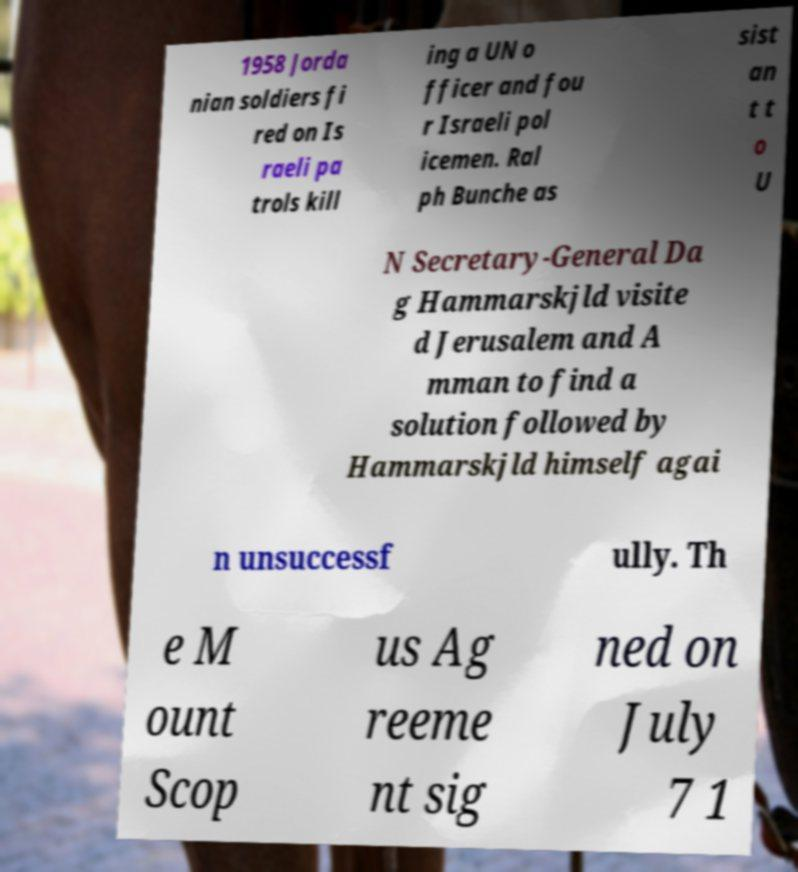Please identify and transcribe the text found in this image. 1958 Jorda nian soldiers fi red on Is raeli pa trols kill ing a UN o fficer and fou r Israeli pol icemen. Ral ph Bunche as sist an t t o U N Secretary-General Da g Hammarskjld visite d Jerusalem and A mman to find a solution followed by Hammarskjld himself agai n unsuccessf ully. Th e M ount Scop us Ag reeme nt sig ned on July 7 1 